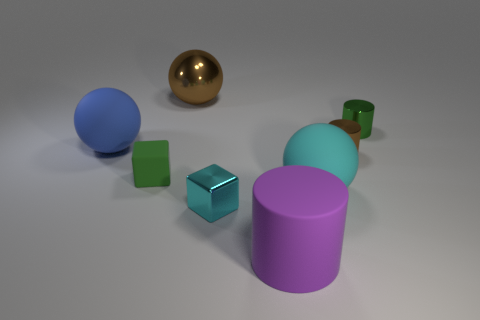Add 1 purple objects. How many objects exist? 9 Subtract all cylinders. How many objects are left? 5 Subtract all tiny green rubber cubes. Subtract all cubes. How many objects are left? 5 Add 2 cyan cubes. How many cyan cubes are left? 3 Add 4 tiny cyan matte spheres. How many tiny cyan matte spheres exist? 4 Subtract 0 gray blocks. How many objects are left? 8 